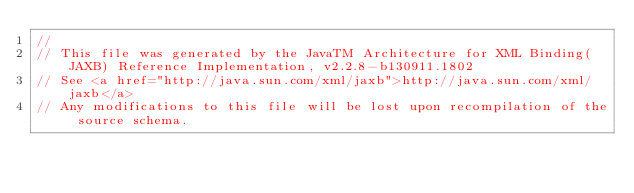Convert code to text. <code><loc_0><loc_0><loc_500><loc_500><_Java_>//
// This file was generated by the JavaTM Architecture for XML Binding(JAXB) Reference Implementation, v2.2.8-b130911.1802 
// See <a href="http://java.sun.com/xml/jaxb">http://java.sun.com/xml/jaxb</a> 
// Any modifications to this file will be lost upon recompilation of the source schema. </code> 